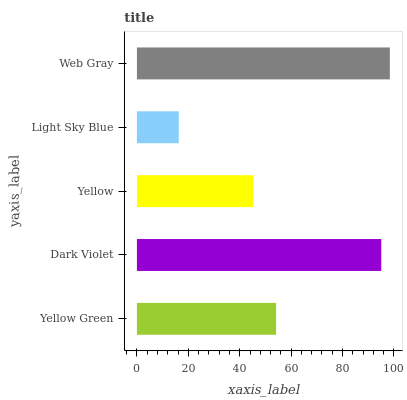Is Light Sky Blue the minimum?
Answer yes or no. Yes. Is Web Gray the maximum?
Answer yes or no. Yes. Is Dark Violet the minimum?
Answer yes or no. No. Is Dark Violet the maximum?
Answer yes or no. No. Is Dark Violet greater than Yellow Green?
Answer yes or no. Yes. Is Yellow Green less than Dark Violet?
Answer yes or no. Yes. Is Yellow Green greater than Dark Violet?
Answer yes or no. No. Is Dark Violet less than Yellow Green?
Answer yes or no. No. Is Yellow Green the high median?
Answer yes or no. Yes. Is Yellow Green the low median?
Answer yes or no. Yes. Is Yellow the high median?
Answer yes or no. No. Is Web Gray the low median?
Answer yes or no. No. 